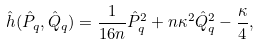<formula> <loc_0><loc_0><loc_500><loc_500>\hat { h } ( \hat { P } _ { q } , \hat { Q } _ { q } ) = \frac { 1 } { 1 6 n } \hat { P } _ { q } ^ { 2 } + n \kappa ^ { 2 } \hat { Q } _ { q } ^ { 2 } - \frac { \kappa } { 4 } ,</formula> 